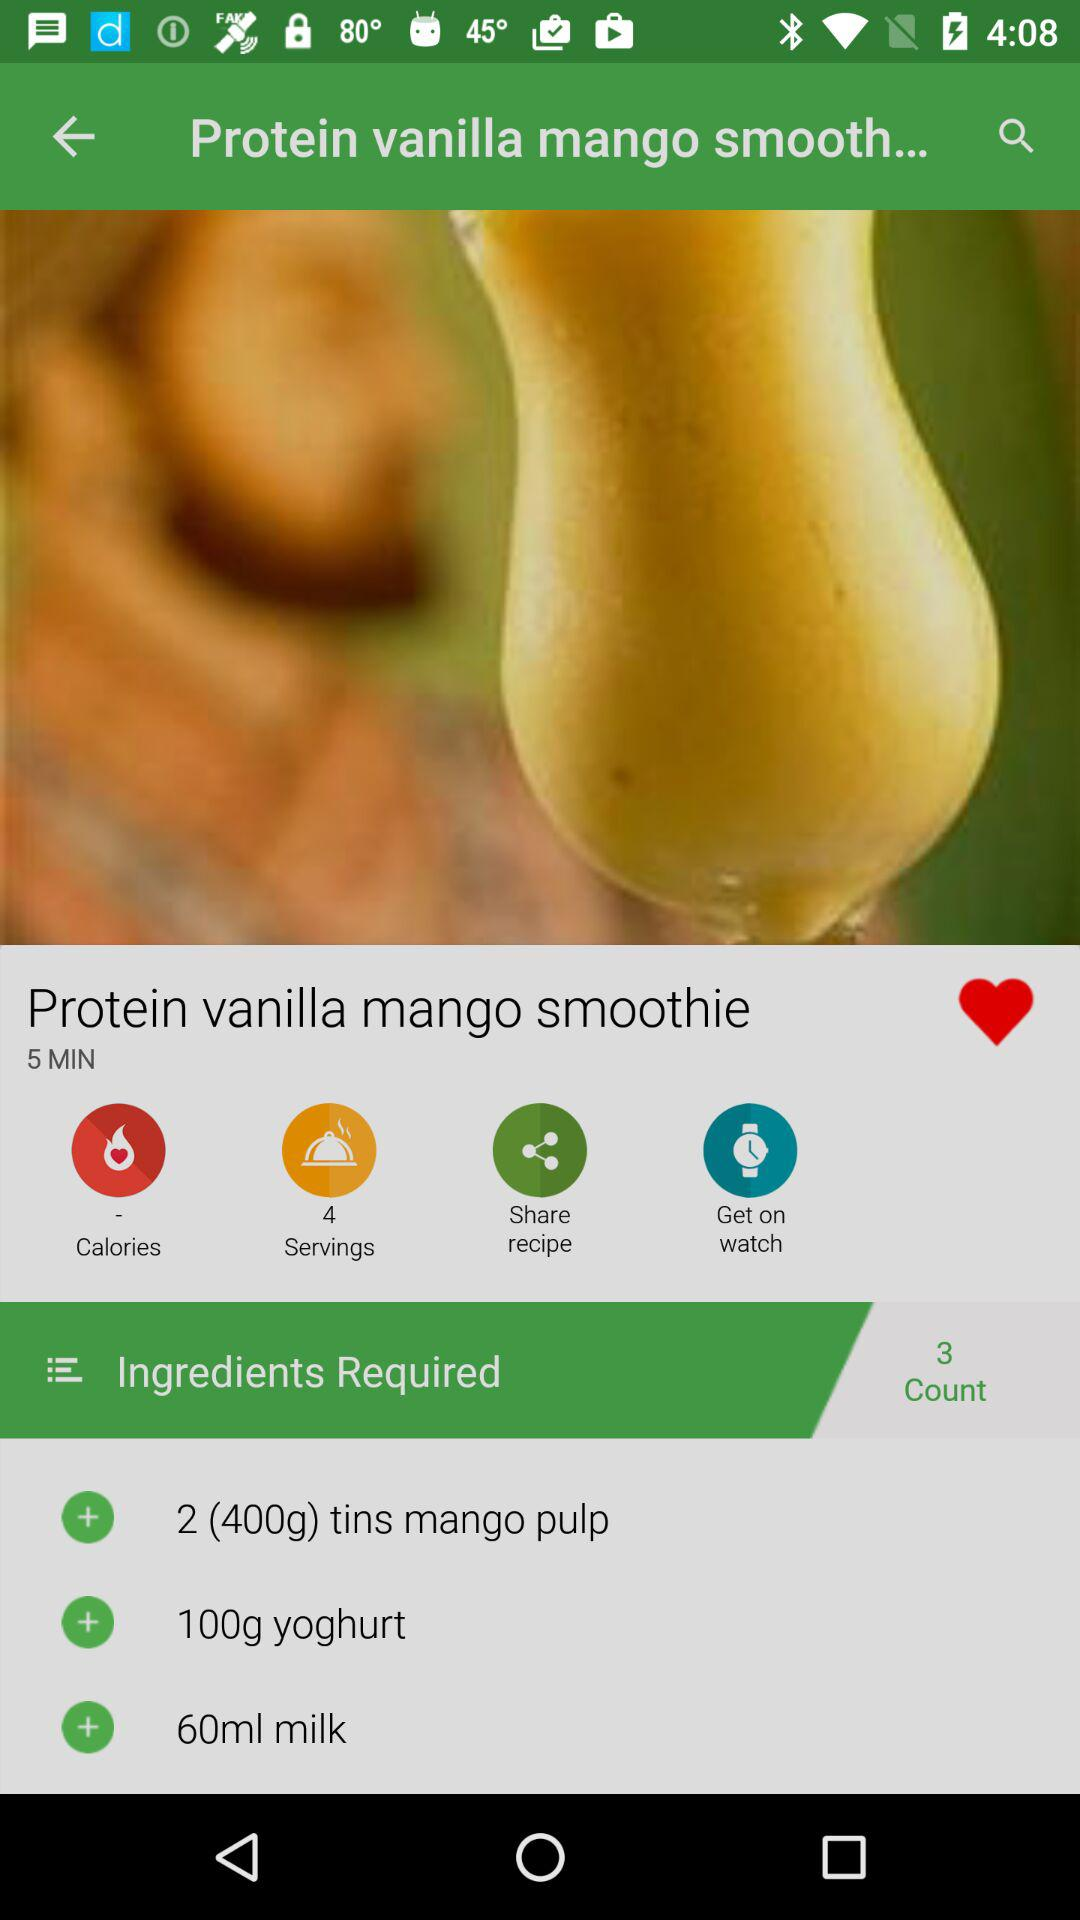How many people can the "Protein vanilla mango smoothie" be served to? The "Protein vanilla mango smoothie" can be served to 4 people. 